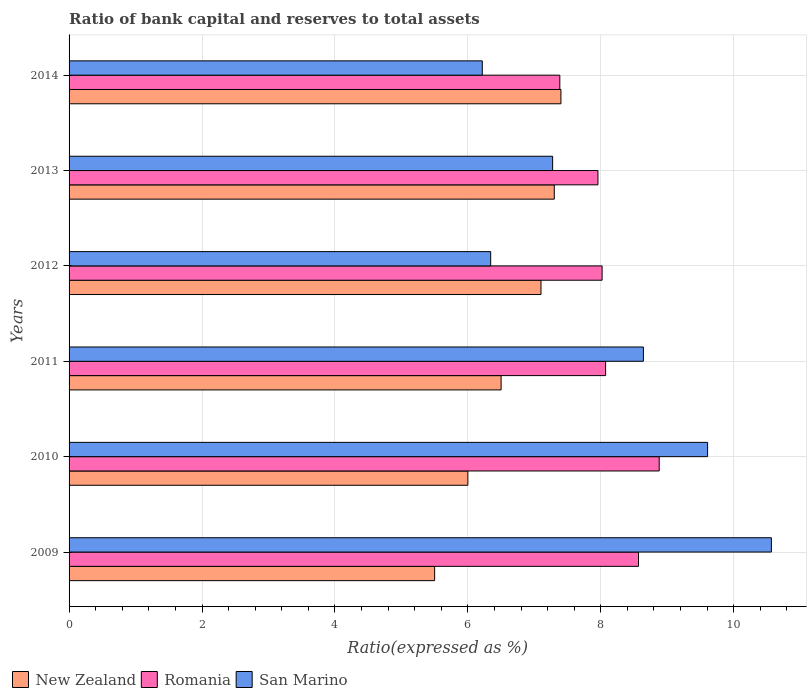How many bars are there on the 3rd tick from the top?
Your response must be concise. 3. How many bars are there on the 3rd tick from the bottom?
Offer a terse response. 3. What is the ratio of bank capital and reserves to total assets in Romania in 2011?
Make the answer very short. 8.07. Across all years, what is the maximum ratio of bank capital and reserves to total assets in San Marino?
Provide a succinct answer. 10.57. Across all years, what is the minimum ratio of bank capital and reserves to total assets in New Zealand?
Your response must be concise. 5.5. In which year was the ratio of bank capital and reserves to total assets in San Marino minimum?
Keep it short and to the point. 2014. What is the total ratio of bank capital and reserves to total assets in San Marino in the graph?
Give a very brief answer. 48.65. What is the difference between the ratio of bank capital and reserves to total assets in San Marino in 2012 and that in 2013?
Make the answer very short. -0.93. What is the difference between the ratio of bank capital and reserves to total assets in Romania in 2011 and the ratio of bank capital and reserves to total assets in San Marino in 2014?
Give a very brief answer. 1.86. What is the average ratio of bank capital and reserves to total assets in Romania per year?
Provide a succinct answer. 8.15. In the year 2012, what is the difference between the ratio of bank capital and reserves to total assets in Romania and ratio of bank capital and reserves to total assets in San Marino?
Make the answer very short. 1.68. What is the ratio of the ratio of bank capital and reserves to total assets in Romania in 2010 to that in 2012?
Give a very brief answer. 1.11. Is the ratio of bank capital and reserves to total assets in Romania in 2011 less than that in 2014?
Ensure brevity in your answer.  No. Is the difference between the ratio of bank capital and reserves to total assets in Romania in 2009 and 2014 greater than the difference between the ratio of bank capital and reserves to total assets in San Marino in 2009 and 2014?
Your response must be concise. No. What is the difference between the highest and the second highest ratio of bank capital and reserves to total assets in New Zealand?
Offer a terse response. 0.1. What is the difference between the highest and the lowest ratio of bank capital and reserves to total assets in Romania?
Ensure brevity in your answer.  1.49. What does the 2nd bar from the top in 2010 represents?
Provide a short and direct response. Romania. What does the 3rd bar from the bottom in 2012 represents?
Your answer should be compact. San Marino. Is it the case that in every year, the sum of the ratio of bank capital and reserves to total assets in San Marino and ratio of bank capital and reserves to total assets in Romania is greater than the ratio of bank capital and reserves to total assets in New Zealand?
Ensure brevity in your answer.  Yes. How many bars are there?
Keep it short and to the point. 18. Does the graph contain any zero values?
Keep it short and to the point. No. Does the graph contain grids?
Keep it short and to the point. Yes. Where does the legend appear in the graph?
Provide a succinct answer. Bottom left. How many legend labels are there?
Make the answer very short. 3. What is the title of the graph?
Make the answer very short. Ratio of bank capital and reserves to total assets. What is the label or title of the X-axis?
Give a very brief answer. Ratio(expressed as %). What is the label or title of the Y-axis?
Keep it short and to the point. Years. What is the Ratio(expressed as %) of New Zealand in 2009?
Your answer should be very brief. 5.5. What is the Ratio(expressed as %) in Romania in 2009?
Keep it short and to the point. 8.57. What is the Ratio(expressed as %) of San Marino in 2009?
Give a very brief answer. 10.57. What is the Ratio(expressed as %) of New Zealand in 2010?
Make the answer very short. 6. What is the Ratio(expressed as %) in Romania in 2010?
Ensure brevity in your answer.  8.88. What is the Ratio(expressed as %) in San Marino in 2010?
Provide a short and direct response. 9.61. What is the Ratio(expressed as %) of Romania in 2011?
Make the answer very short. 8.07. What is the Ratio(expressed as %) in San Marino in 2011?
Offer a very short reply. 8.64. What is the Ratio(expressed as %) in New Zealand in 2012?
Your response must be concise. 7.1. What is the Ratio(expressed as %) in Romania in 2012?
Give a very brief answer. 8.02. What is the Ratio(expressed as %) of San Marino in 2012?
Provide a short and direct response. 6.34. What is the Ratio(expressed as %) of New Zealand in 2013?
Keep it short and to the point. 7.3. What is the Ratio(expressed as %) of Romania in 2013?
Ensure brevity in your answer.  7.96. What is the Ratio(expressed as %) in San Marino in 2013?
Ensure brevity in your answer.  7.28. What is the Ratio(expressed as %) of New Zealand in 2014?
Keep it short and to the point. 7.4. What is the Ratio(expressed as %) in Romania in 2014?
Provide a succinct answer. 7.38. What is the Ratio(expressed as %) in San Marino in 2014?
Your answer should be compact. 6.22. Across all years, what is the maximum Ratio(expressed as %) in Romania?
Provide a succinct answer. 8.88. Across all years, what is the maximum Ratio(expressed as %) of San Marino?
Provide a succinct answer. 10.57. Across all years, what is the minimum Ratio(expressed as %) in Romania?
Your answer should be compact. 7.38. Across all years, what is the minimum Ratio(expressed as %) of San Marino?
Make the answer very short. 6.22. What is the total Ratio(expressed as %) of New Zealand in the graph?
Ensure brevity in your answer.  39.8. What is the total Ratio(expressed as %) of Romania in the graph?
Offer a terse response. 48.88. What is the total Ratio(expressed as %) of San Marino in the graph?
Ensure brevity in your answer.  48.65. What is the difference between the Ratio(expressed as %) in New Zealand in 2009 and that in 2010?
Offer a very short reply. -0.5. What is the difference between the Ratio(expressed as %) in Romania in 2009 and that in 2010?
Provide a succinct answer. -0.31. What is the difference between the Ratio(expressed as %) in San Marino in 2009 and that in 2010?
Keep it short and to the point. 0.96. What is the difference between the Ratio(expressed as %) of Romania in 2009 and that in 2011?
Offer a very short reply. 0.49. What is the difference between the Ratio(expressed as %) of San Marino in 2009 and that in 2011?
Give a very brief answer. 1.93. What is the difference between the Ratio(expressed as %) of New Zealand in 2009 and that in 2012?
Your answer should be very brief. -1.6. What is the difference between the Ratio(expressed as %) of Romania in 2009 and that in 2012?
Ensure brevity in your answer.  0.55. What is the difference between the Ratio(expressed as %) of San Marino in 2009 and that in 2012?
Offer a very short reply. 4.22. What is the difference between the Ratio(expressed as %) in Romania in 2009 and that in 2013?
Provide a succinct answer. 0.61. What is the difference between the Ratio(expressed as %) of San Marino in 2009 and that in 2013?
Keep it short and to the point. 3.29. What is the difference between the Ratio(expressed as %) in Romania in 2009 and that in 2014?
Your response must be concise. 1.18. What is the difference between the Ratio(expressed as %) in San Marino in 2009 and that in 2014?
Give a very brief answer. 4.35. What is the difference between the Ratio(expressed as %) in Romania in 2010 and that in 2011?
Provide a succinct answer. 0.81. What is the difference between the Ratio(expressed as %) in San Marino in 2010 and that in 2011?
Offer a terse response. 0.97. What is the difference between the Ratio(expressed as %) in New Zealand in 2010 and that in 2012?
Make the answer very short. -1.1. What is the difference between the Ratio(expressed as %) of Romania in 2010 and that in 2012?
Offer a very short reply. 0.86. What is the difference between the Ratio(expressed as %) of San Marino in 2010 and that in 2012?
Provide a succinct answer. 3.26. What is the difference between the Ratio(expressed as %) of New Zealand in 2010 and that in 2013?
Offer a very short reply. -1.3. What is the difference between the Ratio(expressed as %) of Romania in 2010 and that in 2013?
Make the answer very short. 0.92. What is the difference between the Ratio(expressed as %) of San Marino in 2010 and that in 2013?
Keep it short and to the point. 2.33. What is the difference between the Ratio(expressed as %) of Romania in 2010 and that in 2014?
Keep it short and to the point. 1.5. What is the difference between the Ratio(expressed as %) of San Marino in 2010 and that in 2014?
Provide a succinct answer. 3.39. What is the difference between the Ratio(expressed as %) in Romania in 2011 and that in 2012?
Your response must be concise. 0.05. What is the difference between the Ratio(expressed as %) in San Marino in 2011 and that in 2012?
Provide a short and direct response. 2.3. What is the difference between the Ratio(expressed as %) of New Zealand in 2011 and that in 2013?
Your answer should be compact. -0.8. What is the difference between the Ratio(expressed as %) in Romania in 2011 and that in 2013?
Provide a short and direct response. 0.12. What is the difference between the Ratio(expressed as %) of San Marino in 2011 and that in 2013?
Your answer should be compact. 1.37. What is the difference between the Ratio(expressed as %) of Romania in 2011 and that in 2014?
Your answer should be compact. 0.69. What is the difference between the Ratio(expressed as %) in San Marino in 2011 and that in 2014?
Your answer should be compact. 2.42. What is the difference between the Ratio(expressed as %) in Romania in 2012 and that in 2013?
Provide a short and direct response. 0.06. What is the difference between the Ratio(expressed as %) of San Marino in 2012 and that in 2013?
Give a very brief answer. -0.93. What is the difference between the Ratio(expressed as %) in New Zealand in 2012 and that in 2014?
Give a very brief answer. -0.3. What is the difference between the Ratio(expressed as %) of Romania in 2012 and that in 2014?
Offer a terse response. 0.64. What is the difference between the Ratio(expressed as %) in San Marino in 2012 and that in 2014?
Give a very brief answer. 0.13. What is the difference between the Ratio(expressed as %) in New Zealand in 2013 and that in 2014?
Give a very brief answer. -0.1. What is the difference between the Ratio(expressed as %) in Romania in 2013 and that in 2014?
Provide a succinct answer. 0.57. What is the difference between the Ratio(expressed as %) in San Marino in 2013 and that in 2014?
Offer a very short reply. 1.06. What is the difference between the Ratio(expressed as %) of New Zealand in 2009 and the Ratio(expressed as %) of Romania in 2010?
Offer a terse response. -3.38. What is the difference between the Ratio(expressed as %) in New Zealand in 2009 and the Ratio(expressed as %) in San Marino in 2010?
Ensure brevity in your answer.  -4.11. What is the difference between the Ratio(expressed as %) of Romania in 2009 and the Ratio(expressed as %) of San Marino in 2010?
Offer a very short reply. -1.04. What is the difference between the Ratio(expressed as %) of New Zealand in 2009 and the Ratio(expressed as %) of Romania in 2011?
Provide a succinct answer. -2.57. What is the difference between the Ratio(expressed as %) of New Zealand in 2009 and the Ratio(expressed as %) of San Marino in 2011?
Your answer should be very brief. -3.14. What is the difference between the Ratio(expressed as %) of Romania in 2009 and the Ratio(expressed as %) of San Marino in 2011?
Your answer should be compact. -0.07. What is the difference between the Ratio(expressed as %) of New Zealand in 2009 and the Ratio(expressed as %) of Romania in 2012?
Keep it short and to the point. -2.52. What is the difference between the Ratio(expressed as %) of New Zealand in 2009 and the Ratio(expressed as %) of San Marino in 2012?
Offer a very short reply. -0.84. What is the difference between the Ratio(expressed as %) in Romania in 2009 and the Ratio(expressed as %) in San Marino in 2012?
Provide a succinct answer. 2.22. What is the difference between the Ratio(expressed as %) of New Zealand in 2009 and the Ratio(expressed as %) of Romania in 2013?
Keep it short and to the point. -2.46. What is the difference between the Ratio(expressed as %) in New Zealand in 2009 and the Ratio(expressed as %) in San Marino in 2013?
Ensure brevity in your answer.  -1.78. What is the difference between the Ratio(expressed as %) in Romania in 2009 and the Ratio(expressed as %) in San Marino in 2013?
Keep it short and to the point. 1.29. What is the difference between the Ratio(expressed as %) in New Zealand in 2009 and the Ratio(expressed as %) in Romania in 2014?
Provide a short and direct response. -1.88. What is the difference between the Ratio(expressed as %) in New Zealand in 2009 and the Ratio(expressed as %) in San Marino in 2014?
Keep it short and to the point. -0.72. What is the difference between the Ratio(expressed as %) in Romania in 2009 and the Ratio(expressed as %) in San Marino in 2014?
Offer a very short reply. 2.35. What is the difference between the Ratio(expressed as %) in New Zealand in 2010 and the Ratio(expressed as %) in Romania in 2011?
Keep it short and to the point. -2.07. What is the difference between the Ratio(expressed as %) in New Zealand in 2010 and the Ratio(expressed as %) in San Marino in 2011?
Your answer should be very brief. -2.64. What is the difference between the Ratio(expressed as %) of Romania in 2010 and the Ratio(expressed as %) of San Marino in 2011?
Give a very brief answer. 0.24. What is the difference between the Ratio(expressed as %) of New Zealand in 2010 and the Ratio(expressed as %) of Romania in 2012?
Give a very brief answer. -2.02. What is the difference between the Ratio(expressed as %) of New Zealand in 2010 and the Ratio(expressed as %) of San Marino in 2012?
Your answer should be very brief. -0.34. What is the difference between the Ratio(expressed as %) of Romania in 2010 and the Ratio(expressed as %) of San Marino in 2012?
Offer a very short reply. 2.54. What is the difference between the Ratio(expressed as %) of New Zealand in 2010 and the Ratio(expressed as %) of Romania in 2013?
Make the answer very short. -1.96. What is the difference between the Ratio(expressed as %) of New Zealand in 2010 and the Ratio(expressed as %) of San Marino in 2013?
Offer a very short reply. -1.28. What is the difference between the Ratio(expressed as %) in Romania in 2010 and the Ratio(expressed as %) in San Marino in 2013?
Offer a terse response. 1.6. What is the difference between the Ratio(expressed as %) in New Zealand in 2010 and the Ratio(expressed as %) in Romania in 2014?
Your response must be concise. -1.38. What is the difference between the Ratio(expressed as %) in New Zealand in 2010 and the Ratio(expressed as %) in San Marino in 2014?
Give a very brief answer. -0.22. What is the difference between the Ratio(expressed as %) of Romania in 2010 and the Ratio(expressed as %) of San Marino in 2014?
Ensure brevity in your answer.  2.66. What is the difference between the Ratio(expressed as %) in New Zealand in 2011 and the Ratio(expressed as %) in Romania in 2012?
Provide a short and direct response. -1.52. What is the difference between the Ratio(expressed as %) of New Zealand in 2011 and the Ratio(expressed as %) of San Marino in 2012?
Provide a succinct answer. 0.16. What is the difference between the Ratio(expressed as %) of Romania in 2011 and the Ratio(expressed as %) of San Marino in 2012?
Offer a terse response. 1.73. What is the difference between the Ratio(expressed as %) in New Zealand in 2011 and the Ratio(expressed as %) in Romania in 2013?
Give a very brief answer. -1.46. What is the difference between the Ratio(expressed as %) of New Zealand in 2011 and the Ratio(expressed as %) of San Marino in 2013?
Offer a very short reply. -0.78. What is the difference between the Ratio(expressed as %) in Romania in 2011 and the Ratio(expressed as %) in San Marino in 2013?
Offer a terse response. 0.8. What is the difference between the Ratio(expressed as %) of New Zealand in 2011 and the Ratio(expressed as %) of Romania in 2014?
Ensure brevity in your answer.  -0.88. What is the difference between the Ratio(expressed as %) of New Zealand in 2011 and the Ratio(expressed as %) of San Marino in 2014?
Keep it short and to the point. 0.28. What is the difference between the Ratio(expressed as %) in Romania in 2011 and the Ratio(expressed as %) in San Marino in 2014?
Offer a very short reply. 1.86. What is the difference between the Ratio(expressed as %) of New Zealand in 2012 and the Ratio(expressed as %) of Romania in 2013?
Provide a succinct answer. -0.86. What is the difference between the Ratio(expressed as %) in New Zealand in 2012 and the Ratio(expressed as %) in San Marino in 2013?
Your response must be concise. -0.18. What is the difference between the Ratio(expressed as %) in Romania in 2012 and the Ratio(expressed as %) in San Marino in 2013?
Ensure brevity in your answer.  0.74. What is the difference between the Ratio(expressed as %) in New Zealand in 2012 and the Ratio(expressed as %) in Romania in 2014?
Ensure brevity in your answer.  -0.28. What is the difference between the Ratio(expressed as %) in New Zealand in 2012 and the Ratio(expressed as %) in San Marino in 2014?
Your response must be concise. 0.88. What is the difference between the Ratio(expressed as %) of Romania in 2012 and the Ratio(expressed as %) of San Marino in 2014?
Your answer should be very brief. 1.8. What is the difference between the Ratio(expressed as %) of New Zealand in 2013 and the Ratio(expressed as %) of Romania in 2014?
Your answer should be very brief. -0.08. What is the difference between the Ratio(expressed as %) in New Zealand in 2013 and the Ratio(expressed as %) in San Marino in 2014?
Offer a terse response. 1.08. What is the difference between the Ratio(expressed as %) in Romania in 2013 and the Ratio(expressed as %) in San Marino in 2014?
Provide a succinct answer. 1.74. What is the average Ratio(expressed as %) in New Zealand per year?
Keep it short and to the point. 6.63. What is the average Ratio(expressed as %) of Romania per year?
Give a very brief answer. 8.15. What is the average Ratio(expressed as %) in San Marino per year?
Keep it short and to the point. 8.11. In the year 2009, what is the difference between the Ratio(expressed as %) in New Zealand and Ratio(expressed as %) in Romania?
Your answer should be very brief. -3.07. In the year 2009, what is the difference between the Ratio(expressed as %) of New Zealand and Ratio(expressed as %) of San Marino?
Give a very brief answer. -5.07. In the year 2009, what is the difference between the Ratio(expressed as %) of Romania and Ratio(expressed as %) of San Marino?
Make the answer very short. -2. In the year 2010, what is the difference between the Ratio(expressed as %) in New Zealand and Ratio(expressed as %) in Romania?
Offer a very short reply. -2.88. In the year 2010, what is the difference between the Ratio(expressed as %) of New Zealand and Ratio(expressed as %) of San Marino?
Give a very brief answer. -3.61. In the year 2010, what is the difference between the Ratio(expressed as %) in Romania and Ratio(expressed as %) in San Marino?
Keep it short and to the point. -0.73. In the year 2011, what is the difference between the Ratio(expressed as %) of New Zealand and Ratio(expressed as %) of Romania?
Your answer should be compact. -1.57. In the year 2011, what is the difference between the Ratio(expressed as %) of New Zealand and Ratio(expressed as %) of San Marino?
Your answer should be compact. -2.14. In the year 2011, what is the difference between the Ratio(expressed as %) of Romania and Ratio(expressed as %) of San Marino?
Your response must be concise. -0.57. In the year 2012, what is the difference between the Ratio(expressed as %) of New Zealand and Ratio(expressed as %) of Romania?
Make the answer very short. -0.92. In the year 2012, what is the difference between the Ratio(expressed as %) in New Zealand and Ratio(expressed as %) in San Marino?
Keep it short and to the point. 0.76. In the year 2012, what is the difference between the Ratio(expressed as %) of Romania and Ratio(expressed as %) of San Marino?
Your answer should be very brief. 1.68. In the year 2013, what is the difference between the Ratio(expressed as %) of New Zealand and Ratio(expressed as %) of Romania?
Give a very brief answer. -0.66. In the year 2013, what is the difference between the Ratio(expressed as %) in New Zealand and Ratio(expressed as %) in San Marino?
Offer a terse response. 0.02. In the year 2013, what is the difference between the Ratio(expressed as %) in Romania and Ratio(expressed as %) in San Marino?
Offer a terse response. 0.68. In the year 2014, what is the difference between the Ratio(expressed as %) of New Zealand and Ratio(expressed as %) of Romania?
Keep it short and to the point. 0.02. In the year 2014, what is the difference between the Ratio(expressed as %) of New Zealand and Ratio(expressed as %) of San Marino?
Ensure brevity in your answer.  1.18. In the year 2014, what is the difference between the Ratio(expressed as %) in Romania and Ratio(expressed as %) in San Marino?
Ensure brevity in your answer.  1.17. What is the ratio of the Ratio(expressed as %) of New Zealand in 2009 to that in 2010?
Give a very brief answer. 0.92. What is the ratio of the Ratio(expressed as %) in Romania in 2009 to that in 2010?
Keep it short and to the point. 0.96. What is the ratio of the Ratio(expressed as %) of San Marino in 2009 to that in 2010?
Keep it short and to the point. 1.1. What is the ratio of the Ratio(expressed as %) in New Zealand in 2009 to that in 2011?
Provide a succinct answer. 0.85. What is the ratio of the Ratio(expressed as %) of Romania in 2009 to that in 2011?
Make the answer very short. 1.06. What is the ratio of the Ratio(expressed as %) in San Marino in 2009 to that in 2011?
Your response must be concise. 1.22. What is the ratio of the Ratio(expressed as %) of New Zealand in 2009 to that in 2012?
Your answer should be compact. 0.77. What is the ratio of the Ratio(expressed as %) in Romania in 2009 to that in 2012?
Your answer should be very brief. 1.07. What is the ratio of the Ratio(expressed as %) in San Marino in 2009 to that in 2012?
Give a very brief answer. 1.67. What is the ratio of the Ratio(expressed as %) in New Zealand in 2009 to that in 2013?
Your answer should be very brief. 0.75. What is the ratio of the Ratio(expressed as %) in Romania in 2009 to that in 2013?
Offer a terse response. 1.08. What is the ratio of the Ratio(expressed as %) of San Marino in 2009 to that in 2013?
Your answer should be very brief. 1.45. What is the ratio of the Ratio(expressed as %) of New Zealand in 2009 to that in 2014?
Provide a succinct answer. 0.74. What is the ratio of the Ratio(expressed as %) of Romania in 2009 to that in 2014?
Make the answer very short. 1.16. What is the ratio of the Ratio(expressed as %) of San Marino in 2009 to that in 2014?
Offer a terse response. 1.7. What is the ratio of the Ratio(expressed as %) of Romania in 2010 to that in 2011?
Your answer should be very brief. 1.1. What is the ratio of the Ratio(expressed as %) of San Marino in 2010 to that in 2011?
Provide a succinct answer. 1.11. What is the ratio of the Ratio(expressed as %) in New Zealand in 2010 to that in 2012?
Make the answer very short. 0.85. What is the ratio of the Ratio(expressed as %) of Romania in 2010 to that in 2012?
Your answer should be compact. 1.11. What is the ratio of the Ratio(expressed as %) of San Marino in 2010 to that in 2012?
Provide a short and direct response. 1.51. What is the ratio of the Ratio(expressed as %) of New Zealand in 2010 to that in 2013?
Your answer should be compact. 0.82. What is the ratio of the Ratio(expressed as %) in Romania in 2010 to that in 2013?
Provide a succinct answer. 1.12. What is the ratio of the Ratio(expressed as %) of San Marino in 2010 to that in 2013?
Give a very brief answer. 1.32. What is the ratio of the Ratio(expressed as %) in New Zealand in 2010 to that in 2014?
Your answer should be very brief. 0.81. What is the ratio of the Ratio(expressed as %) in Romania in 2010 to that in 2014?
Your answer should be compact. 1.2. What is the ratio of the Ratio(expressed as %) of San Marino in 2010 to that in 2014?
Your answer should be very brief. 1.55. What is the ratio of the Ratio(expressed as %) in New Zealand in 2011 to that in 2012?
Your response must be concise. 0.92. What is the ratio of the Ratio(expressed as %) of Romania in 2011 to that in 2012?
Provide a short and direct response. 1.01. What is the ratio of the Ratio(expressed as %) of San Marino in 2011 to that in 2012?
Keep it short and to the point. 1.36. What is the ratio of the Ratio(expressed as %) of New Zealand in 2011 to that in 2013?
Keep it short and to the point. 0.89. What is the ratio of the Ratio(expressed as %) of Romania in 2011 to that in 2013?
Offer a very short reply. 1.01. What is the ratio of the Ratio(expressed as %) in San Marino in 2011 to that in 2013?
Make the answer very short. 1.19. What is the ratio of the Ratio(expressed as %) in New Zealand in 2011 to that in 2014?
Make the answer very short. 0.88. What is the ratio of the Ratio(expressed as %) of Romania in 2011 to that in 2014?
Give a very brief answer. 1.09. What is the ratio of the Ratio(expressed as %) in San Marino in 2011 to that in 2014?
Your answer should be very brief. 1.39. What is the ratio of the Ratio(expressed as %) of New Zealand in 2012 to that in 2013?
Ensure brevity in your answer.  0.97. What is the ratio of the Ratio(expressed as %) of Romania in 2012 to that in 2013?
Offer a terse response. 1.01. What is the ratio of the Ratio(expressed as %) in San Marino in 2012 to that in 2013?
Provide a succinct answer. 0.87. What is the ratio of the Ratio(expressed as %) of New Zealand in 2012 to that in 2014?
Give a very brief answer. 0.96. What is the ratio of the Ratio(expressed as %) of Romania in 2012 to that in 2014?
Offer a very short reply. 1.09. What is the ratio of the Ratio(expressed as %) of San Marino in 2012 to that in 2014?
Keep it short and to the point. 1.02. What is the ratio of the Ratio(expressed as %) in New Zealand in 2013 to that in 2014?
Your answer should be very brief. 0.99. What is the ratio of the Ratio(expressed as %) in Romania in 2013 to that in 2014?
Your answer should be very brief. 1.08. What is the ratio of the Ratio(expressed as %) in San Marino in 2013 to that in 2014?
Offer a very short reply. 1.17. What is the difference between the highest and the second highest Ratio(expressed as %) in Romania?
Keep it short and to the point. 0.31. What is the difference between the highest and the second highest Ratio(expressed as %) of San Marino?
Give a very brief answer. 0.96. What is the difference between the highest and the lowest Ratio(expressed as %) in New Zealand?
Provide a short and direct response. 1.9. What is the difference between the highest and the lowest Ratio(expressed as %) of Romania?
Offer a terse response. 1.5. What is the difference between the highest and the lowest Ratio(expressed as %) in San Marino?
Make the answer very short. 4.35. 